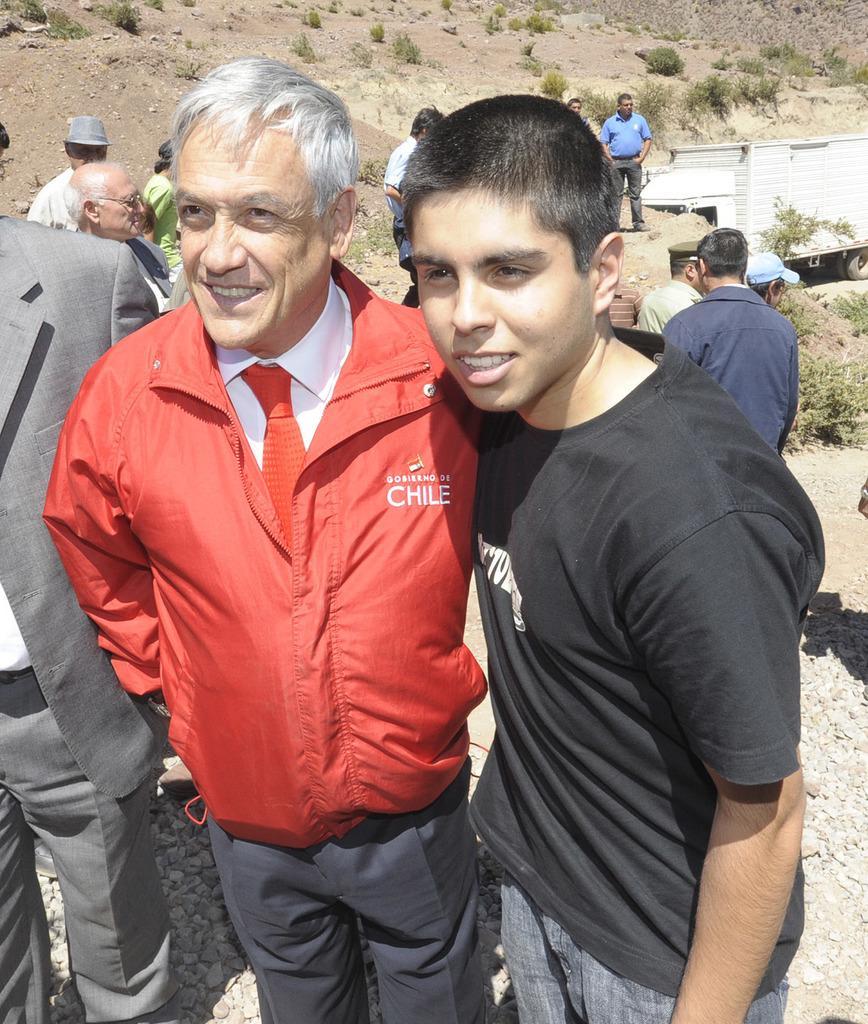Please provide a concise description of this image. In the image we can see there are people standing and a person is wearing red colour jacket and red colour tie. Behind there are other people standing and there are small plants on the ground. 